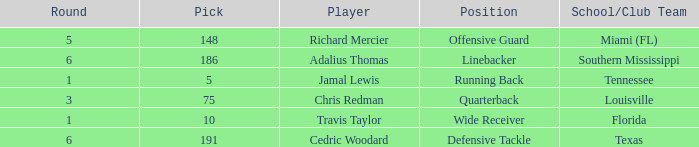Where's the first round that southern mississippi shows up during the draft? 6.0. 